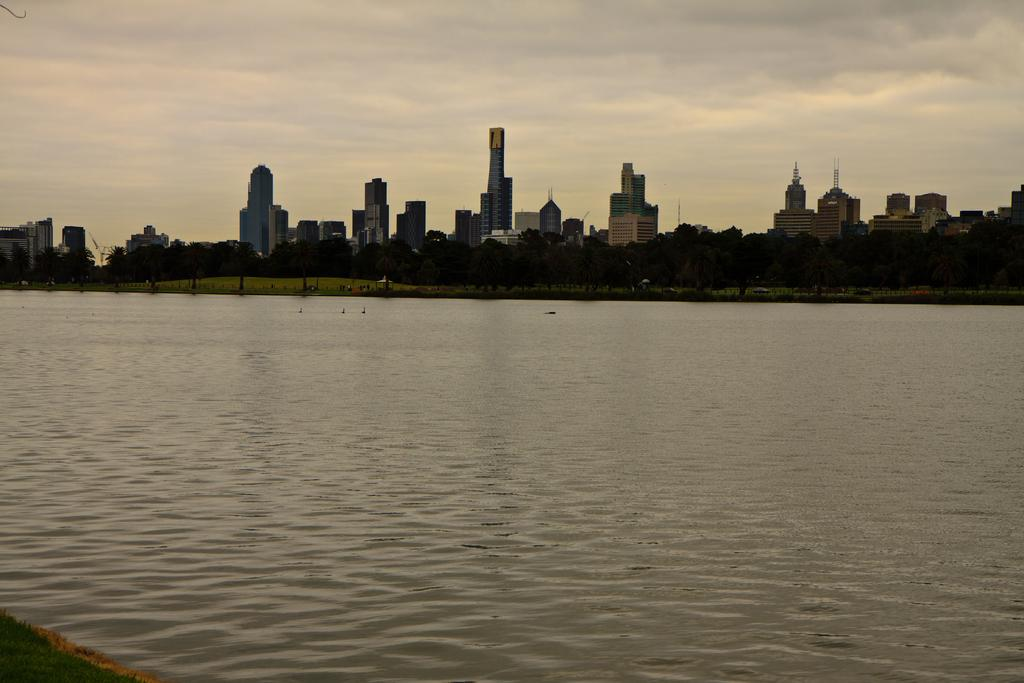What type of structures can be seen in the image? There are many buildings in the image. What natural elements are present in the image? There are trees and grass in the image. What body of water can be seen in the image? There is water visible in the image. What is the condition of the sky in the image? The sky is cloudy in the image. What type of ear is visible in the image? There is no ear present in the image. What type of curtain can be seen hanging from the buildings in the image? There is no curtain visible in the image; only buildings, trees, grass, water, and the sky are present. 